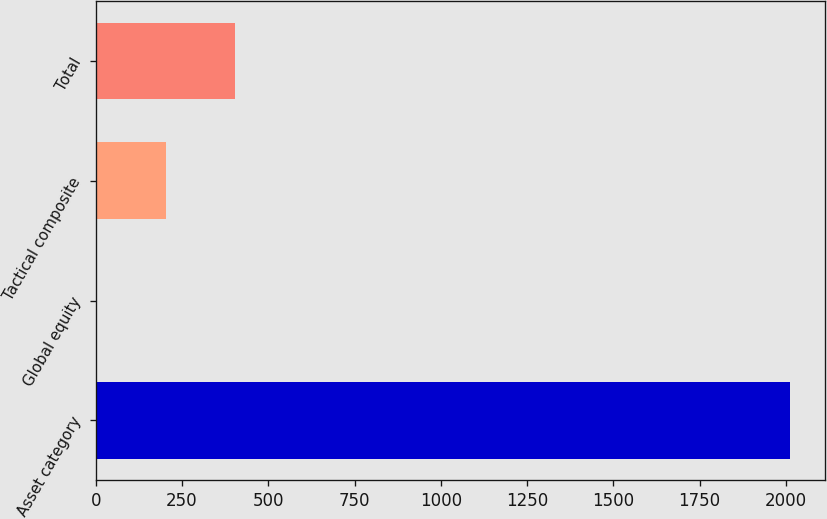Convert chart to OTSL. <chart><loc_0><loc_0><loc_500><loc_500><bar_chart><fcel>Asset category<fcel>Global equity<fcel>Tactical composite<fcel>Total<nl><fcel>2013<fcel>1.1<fcel>202.29<fcel>403.48<nl></chart> 